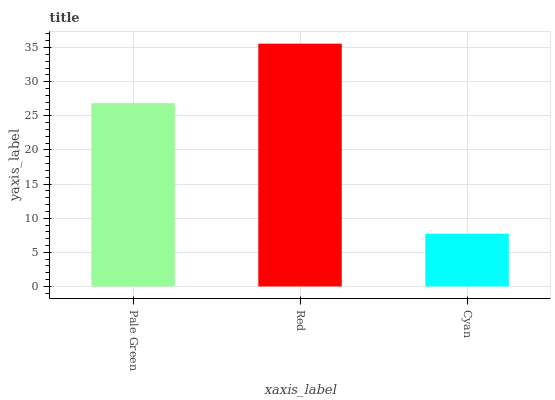Is Red the minimum?
Answer yes or no. No. Is Cyan the maximum?
Answer yes or no. No. Is Red greater than Cyan?
Answer yes or no. Yes. Is Cyan less than Red?
Answer yes or no. Yes. Is Cyan greater than Red?
Answer yes or no. No. Is Red less than Cyan?
Answer yes or no. No. Is Pale Green the high median?
Answer yes or no. Yes. Is Pale Green the low median?
Answer yes or no. Yes. Is Red the high median?
Answer yes or no. No. Is Cyan the low median?
Answer yes or no. No. 